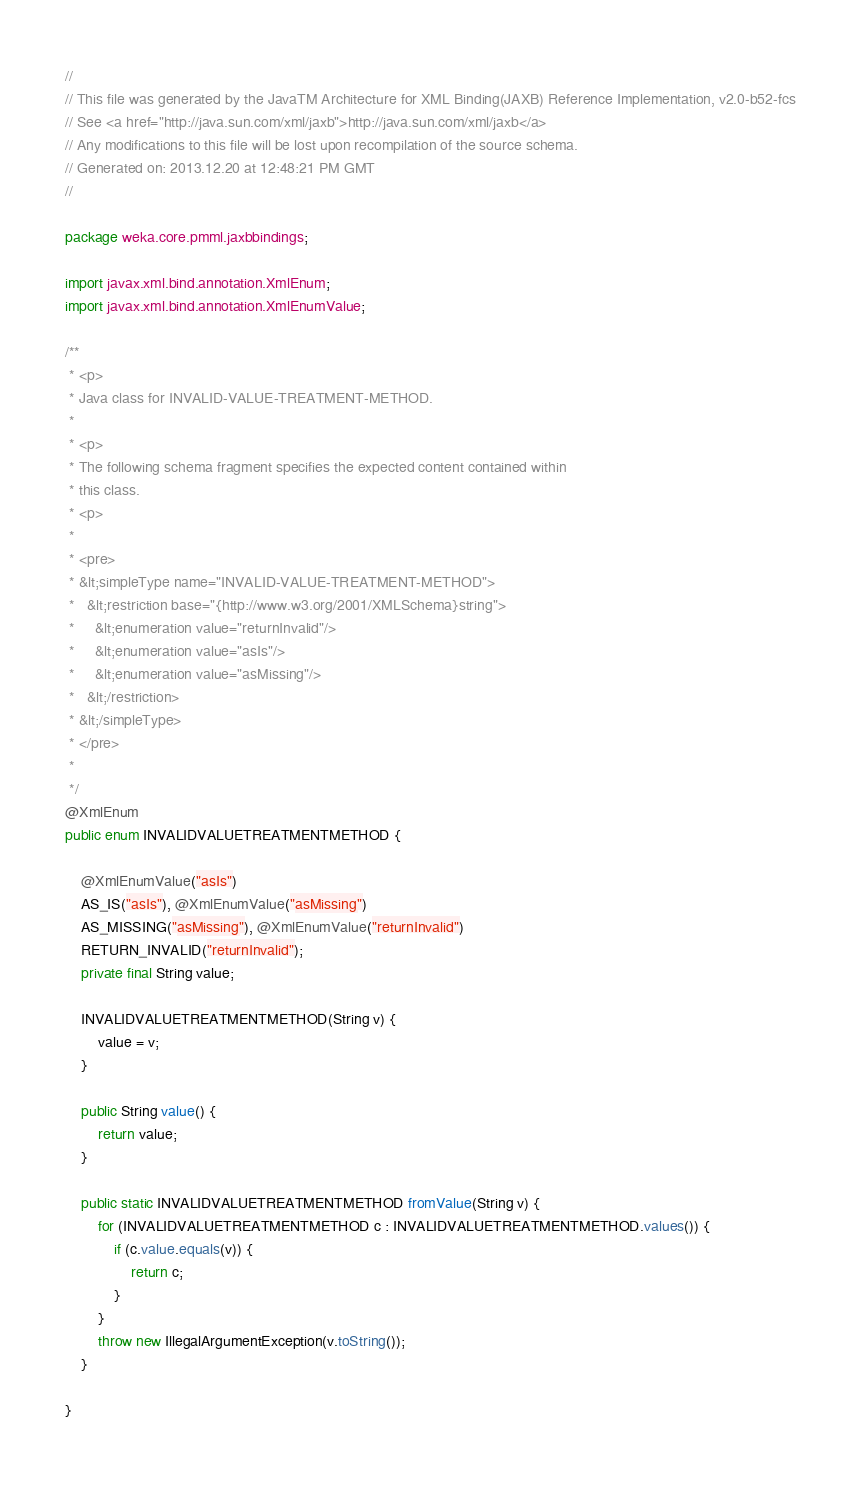Convert code to text. <code><loc_0><loc_0><loc_500><loc_500><_Java_>//
// This file was generated by the JavaTM Architecture for XML Binding(JAXB) Reference Implementation, v2.0-b52-fcs 
// See <a href="http://java.sun.com/xml/jaxb">http://java.sun.com/xml/jaxb</a> 
// Any modifications to this file will be lost upon recompilation of the source schema. 
// Generated on: 2013.12.20 at 12:48:21 PM GMT 
//

package weka.core.pmml.jaxbbindings;

import javax.xml.bind.annotation.XmlEnum;
import javax.xml.bind.annotation.XmlEnumValue;

/**
 * <p>
 * Java class for INVALID-VALUE-TREATMENT-METHOD.
 * 
 * <p>
 * The following schema fragment specifies the expected content contained within
 * this class.
 * <p>
 * 
 * <pre>
 * &lt;simpleType name="INVALID-VALUE-TREATMENT-METHOD">
 *   &lt;restriction base="{http://www.w3.org/2001/XMLSchema}string">
 *     &lt;enumeration value="returnInvalid"/>
 *     &lt;enumeration value="asIs"/>
 *     &lt;enumeration value="asMissing"/>
 *   &lt;/restriction>
 * &lt;/simpleType>
 * </pre>
 * 
 */
@XmlEnum
public enum INVALIDVALUETREATMENTMETHOD {

    @XmlEnumValue("asIs")
    AS_IS("asIs"), @XmlEnumValue("asMissing")
    AS_MISSING("asMissing"), @XmlEnumValue("returnInvalid")
    RETURN_INVALID("returnInvalid");
    private final String value;

    INVALIDVALUETREATMENTMETHOD(String v) {
        value = v;
    }

    public String value() {
        return value;
    }

    public static INVALIDVALUETREATMENTMETHOD fromValue(String v) {
        for (INVALIDVALUETREATMENTMETHOD c : INVALIDVALUETREATMENTMETHOD.values()) {
            if (c.value.equals(v)) {
                return c;
            }
        }
        throw new IllegalArgumentException(v.toString());
    }

}
</code> 